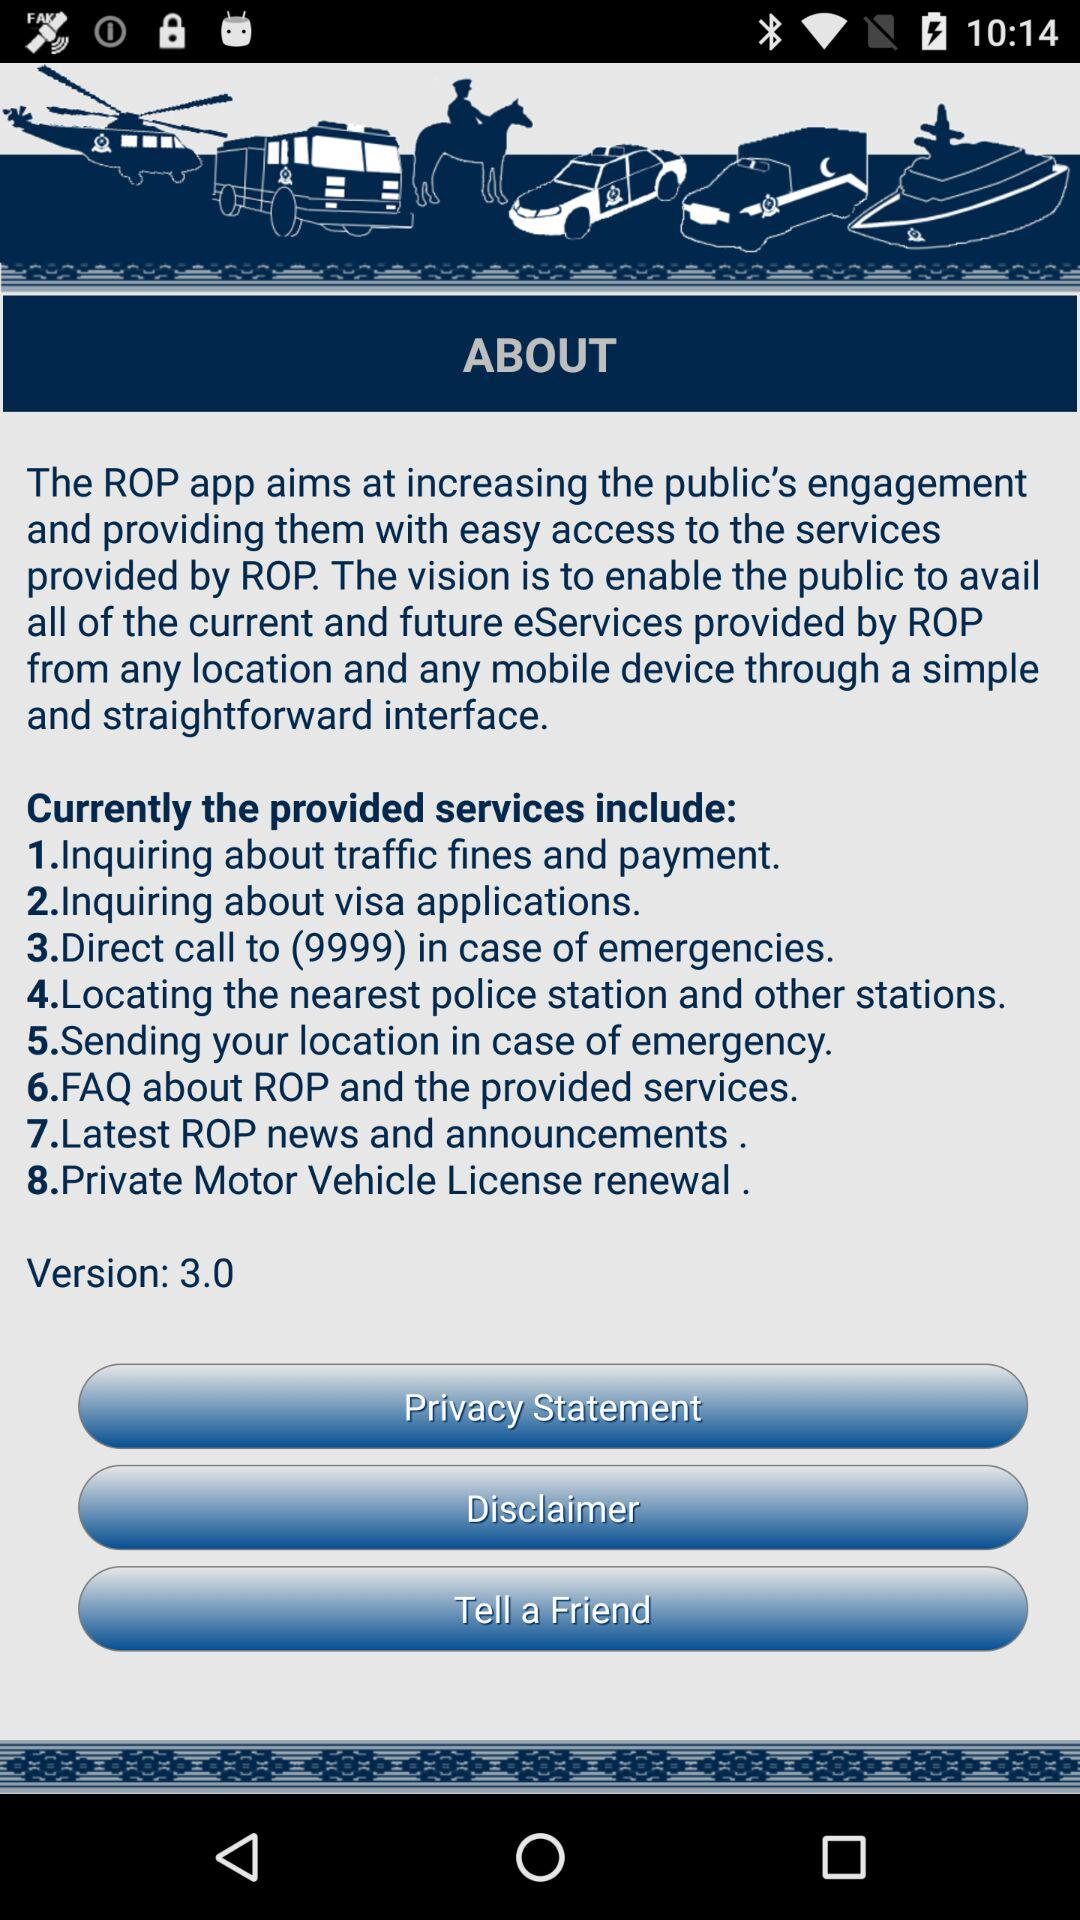How many services are provided by ROP?
Answer the question using a single word or phrase. 8 